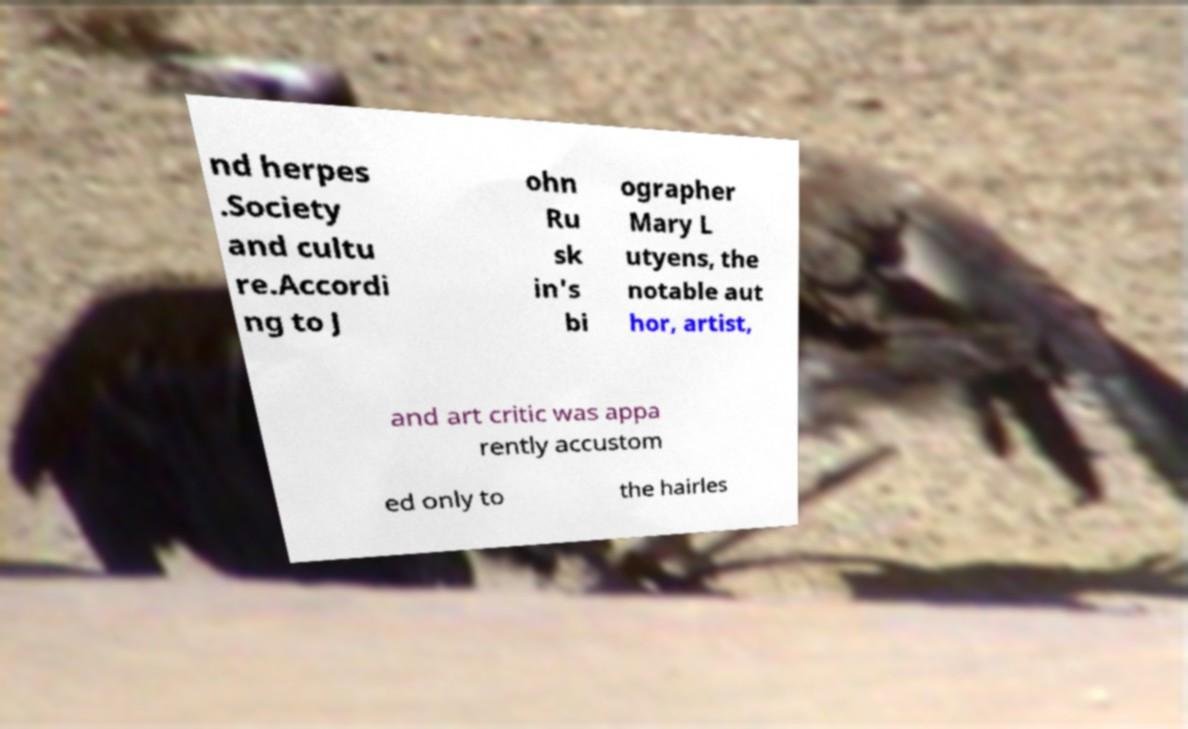Can you accurately transcribe the text from the provided image for me? nd herpes .Society and cultu re.Accordi ng to J ohn Ru sk in's bi ographer Mary L utyens, the notable aut hor, artist, and art critic was appa rently accustom ed only to the hairles 